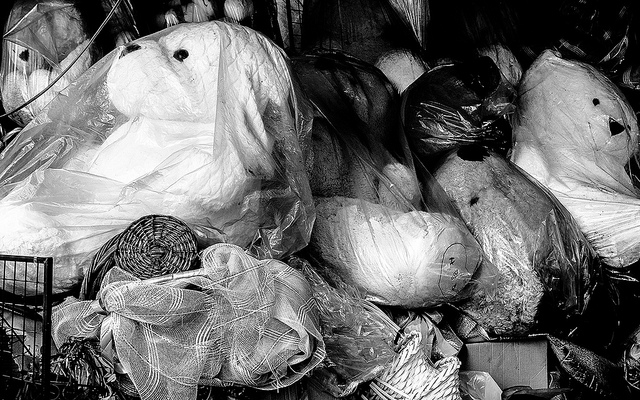Can you describe the condition of the items seen in the photograph? Certainly. The items in the photograph appear to be used and are packed in a haphazard manner. They're wrapped in protective plastic, which suggests they may be stored for later use, sold as second-hand goods, or possibly prepared for transportation. The various states of wear and the fact they're not on display hints at a transitional phase, perhaps between owners or locations. 